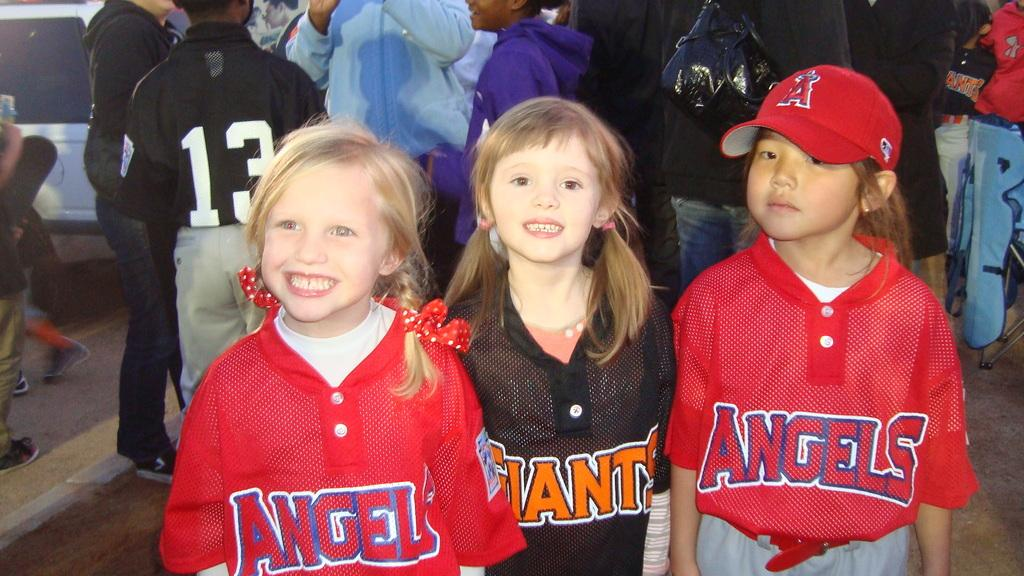<image>
Write a terse but informative summary of the picture. A group of children are wearing baseball uniforms that say Angels and Giants. 